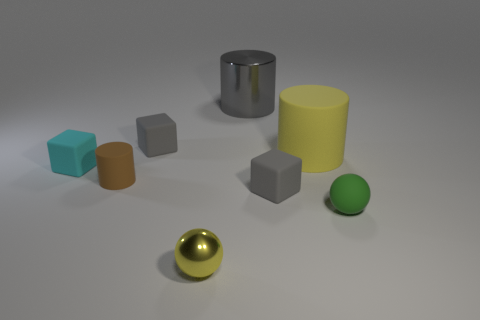Is there any pattern to how the objects are arranged? The objects are arranged in a somewhat scattered manner across the surface with no clear pattern. They are neither in a straight line nor grouped by size or color, which gives a random, casual placement to the scene. 